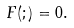<formula> <loc_0><loc_0><loc_500><loc_500>F ( ; ) = 0 .</formula> 